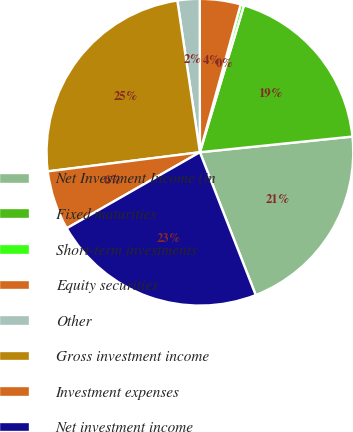<chart> <loc_0><loc_0><loc_500><loc_500><pie_chart><fcel>Net Investment Income (in<fcel>Fixed maturities<fcel>Short-term investments<fcel>Equity securities<fcel>Other<fcel>Gross investment income<fcel>Investment expenses<fcel>Net investment income<nl><fcel>20.7%<fcel>18.73%<fcel>0.36%<fcel>4.3%<fcel>2.33%<fcel>24.64%<fcel>6.27%<fcel>22.67%<nl></chart> 